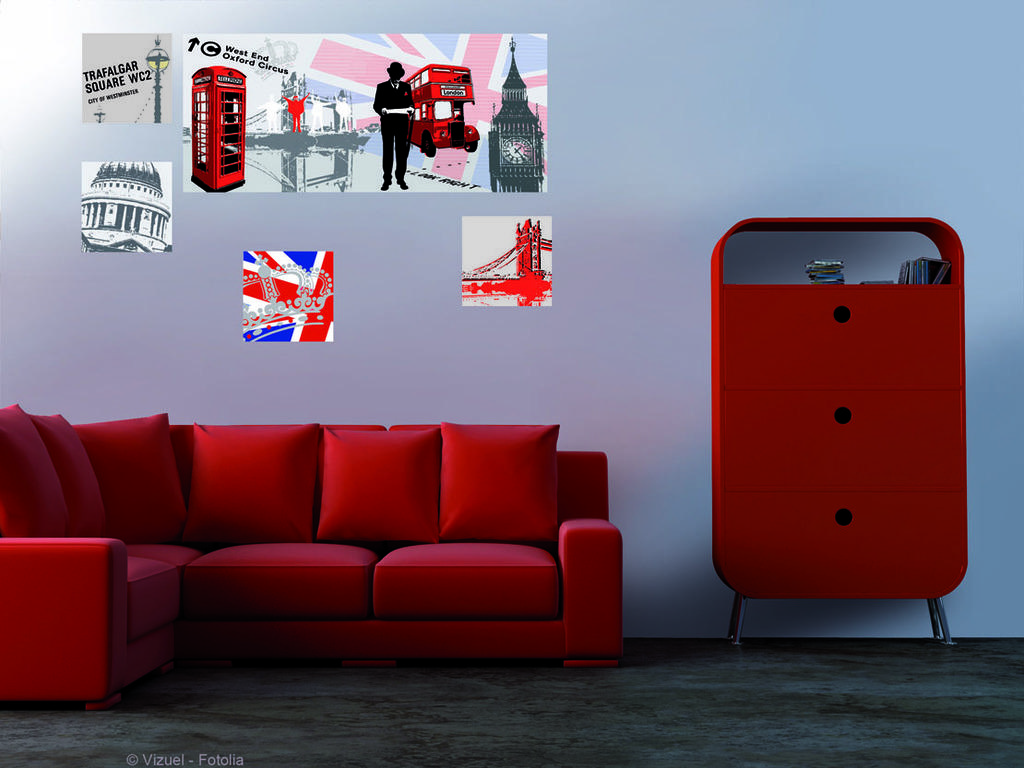What color is the sofa in the image? The sofa in the image is red. What is placed on the sofa? Pillows are on the sofa. What is located behind the sofa? There is a cupboard behind the sofa. What can be seen on the cupboard? There are items on the cupboard. What is hanging on the wall in the image? There are pictures on the wall. What type of frame is visible around the hole in the wall in the image? There is no hole or frame present in the image; it only features a red sofa, pillows, a cupboard, items on the cupboard, and pictures on the wall. 